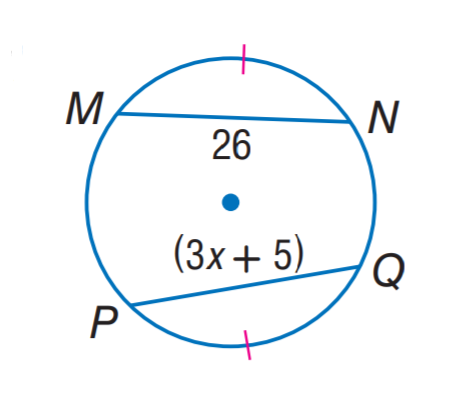Answer the mathemtical geometry problem and directly provide the correct option letter.
Question: Find x.
Choices: A: 5 B: 7 C: 8 D: 26 B 